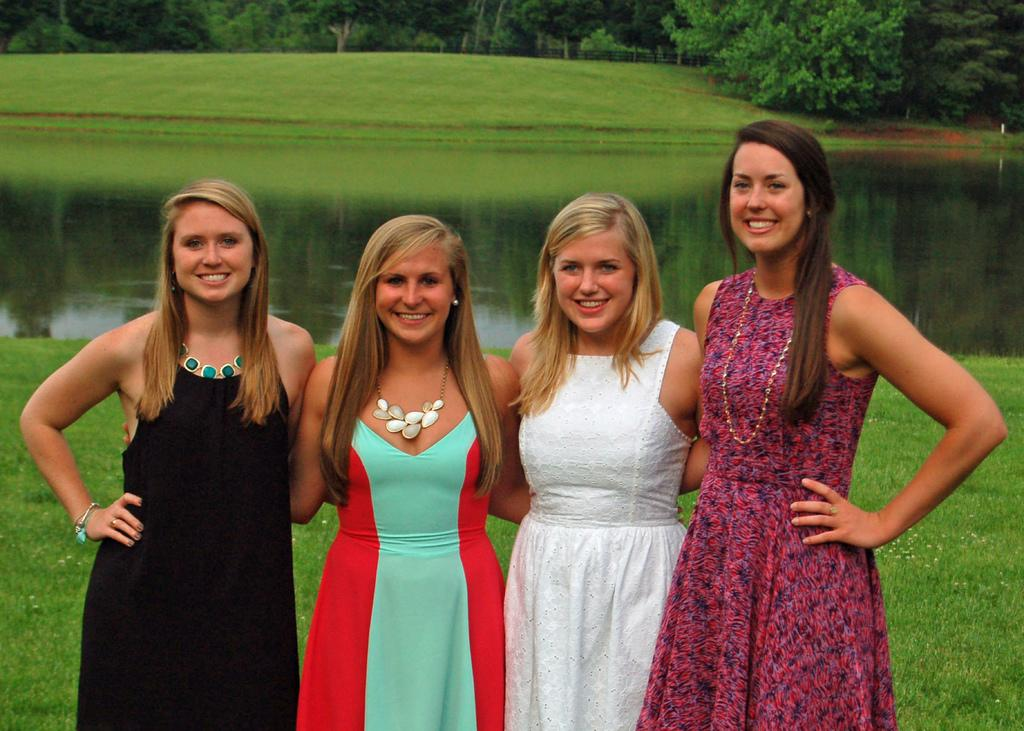How many people are in the image? There are four women in the image. What type of natural environment is visible in the image? Grass and trees are present in the image, suggesting a natural setting. Can you describe the water visible in the image? There is water visible in the image, but its specific characteristics are not mentioned in the facts. What is visible in the background of the image? There are trees in the background of the image. What idea does the grandmother share with her daughter in the image? There is no mention of a grandmother or daughter in the image, nor is there any indication of a conversation or idea being shared. 